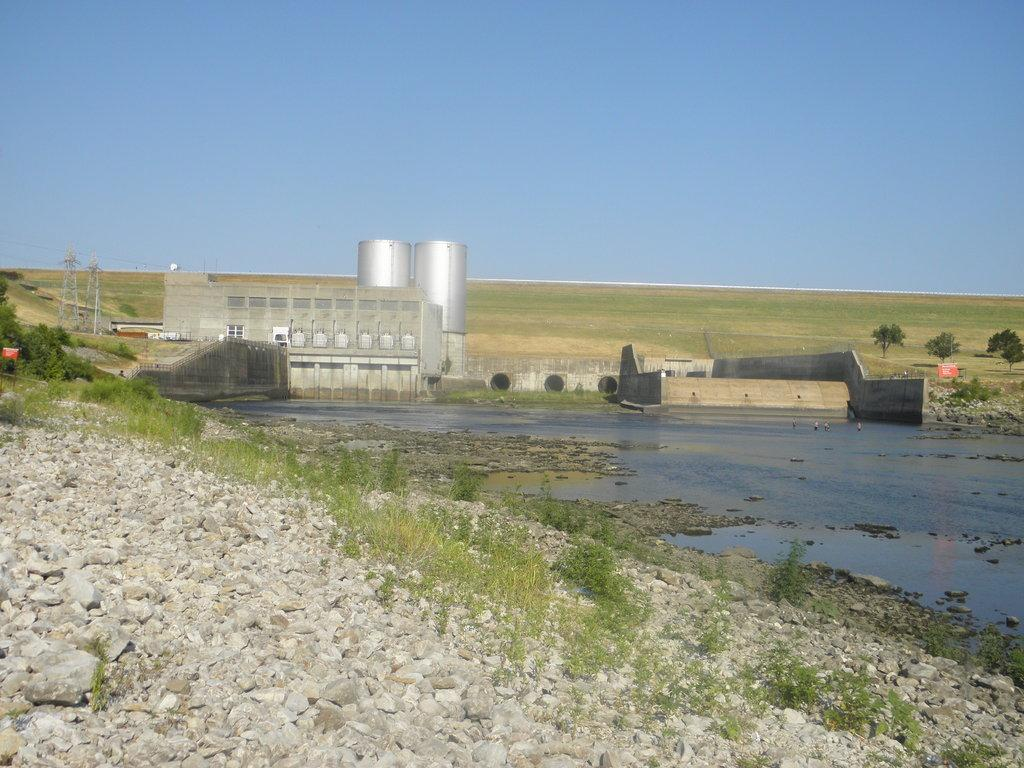What type of natural elements can be seen in the image? There are stones in the image. What is the color of the plants and trees in the image? The plants and trees are green. What can be seen in the background of the image? There is water, a gray building, and towers visible in the background. What is the color of the sky in the image? The sky is blue. Where is the cave located in the image? There is no cave present in the image. What type of flame can be seen coming from the towers in the image? There are no flames visible in the image, and the towers are not on fire. 